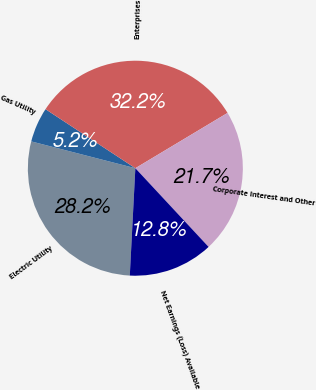Convert chart to OTSL. <chart><loc_0><loc_0><loc_500><loc_500><pie_chart><fcel>Electric Utility<fcel>Gas Utility<fcel>Enterprises<fcel>Corporate Interest and Other<fcel>Net Earnings (Loss) Available<nl><fcel>28.19%<fcel>5.24%<fcel>32.15%<fcel>21.67%<fcel>12.75%<nl></chart> 